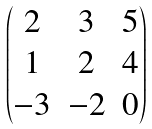Convert formula to latex. <formula><loc_0><loc_0><loc_500><loc_500>\begin{pmatrix} 2 & 3 & 5 \\ 1 & 2 & 4 \\ - 3 & - 2 & 0 \end{pmatrix}</formula> 